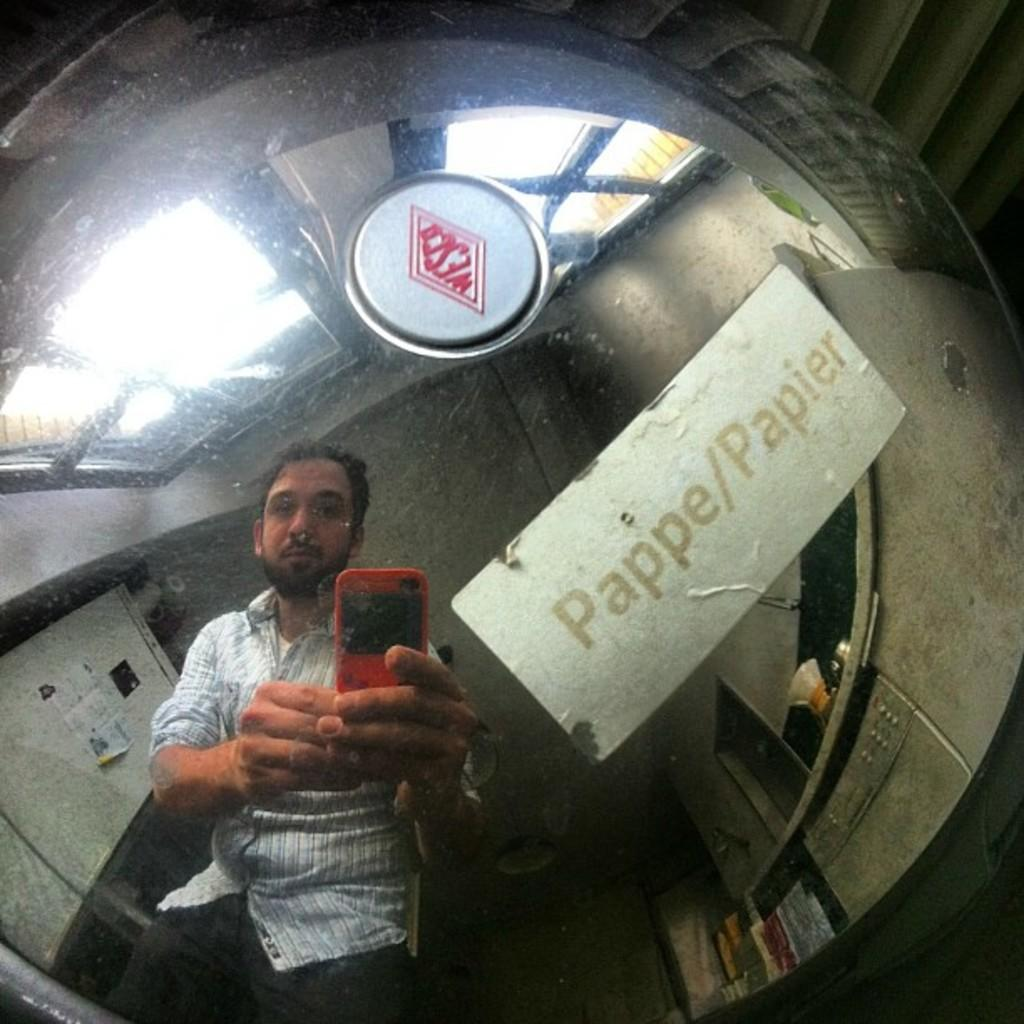What can be seen in the image that resembles a person? There is a reflection of a person in the image. What is the person holding in the image? The person is holding a red mobile phone. What type of furniture is present in the image? There are cabinets in the image. What allows natural light into the room in the image? There are windows in the image. Where is the kitten playing with the lock in the image? There is no kitten or lock present in the image. What type of sun can be seen shining through the windows in the image? There is no sun visible in the image; only the reflection of a person and the cabinets can be seen. 